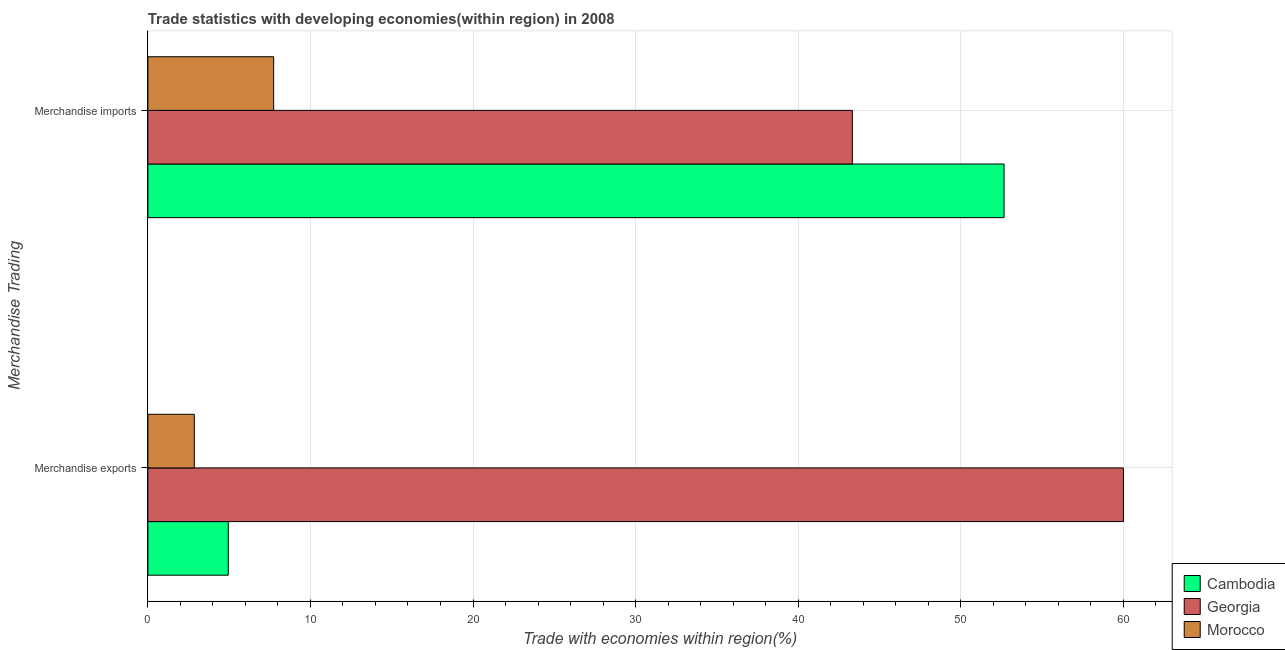How many different coloured bars are there?
Make the answer very short. 3. Are the number of bars per tick equal to the number of legend labels?
Provide a short and direct response. Yes. What is the label of the 2nd group of bars from the top?
Provide a short and direct response. Merchandise exports. What is the merchandise exports in Georgia?
Your answer should be compact. 60.01. Across all countries, what is the maximum merchandise imports?
Keep it short and to the point. 52.67. Across all countries, what is the minimum merchandise exports?
Make the answer very short. 2.86. In which country was the merchandise imports maximum?
Your answer should be compact. Cambodia. In which country was the merchandise imports minimum?
Provide a succinct answer. Morocco. What is the total merchandise exports in the graph?
Your response must be concise. 67.81. What is the difference between the merchandise imports in Morocco and that in Georgia?
Offer a very short reply. -35.6. What is the difference between the merchandise exports in Cambodia and the merchandise imports in Georgia?
Make the answer very short. -38.39. What is the average merchandise imports per country?
Offer a very short reply. 34.58. What is the difference between the merchandise imports and merchandise exports in Cambodia?
Provide a succinct answer. 47.72. What is the ratio of the merchandise imports in Cambodia to that in Morocco?
Your response must be concise. 6.81. Is the merchandise imports in Georgia less than that in Cambodia?
Offer a very short reply. Yes. In how many countries, is the merchandise imports greater than the average merchandise imports taken over all countries?
Your response must be concise. 2. What does the 2nd bar from the top in Merchandise exports represents?
Make the answer very short. Georgia. What does the 1st bar from the bottom in Merchandise exports represents?
Offer a very short reply. Cambodia. Are all the bars in the graph horizontal?
Make the answer very short. Yes. How many countries are there in the graph?
Ensure brevity in your answer.  3. Are the values on the major ticks of X-axis written in scientific E-notation?
Your answer should be compact. No. What is the title of the graph?
Provide a succinct answer. Trade statistics with developing economies(within region) in 2008. What is the label or title of the X-axis?
Your answer should be very brief. Trade with economies within region(%). What is the label or title of the Y-axis?
Provide a short and direct response. Merchandise Trading. What is the Trade with economies within region(%) in Cambodia in Merchandise exports?
Your answer should be very brief. 4.95. What is the Trade with economies within region(%) of Georgia in Merchandise exports?
Provide a succinct answer. 60.01. What is the Trade with economies within region(%) of Morocco in Merchandise exports?
Your response must be concise. 2.86. What is the Trade with economies within region(%) in Cambodia in Merchandise imports?
Give a very brief answer. 52.67. What is the Trade with economies within region(%) in Georgia in Merchandise imports?
Offer a terse response. 43.33. What is the Trade with economies within region(%) of Morocco in Merchandise imports?
Make the answer very short. 7.74. Across all Merchandise Trading, what is the maximum Trade with economies within region(%) in Cambodia?
Your answer should be compact. 52.67. Across all Merchandise Trading, what is the maximum Trade with economies within region(%) in Georgia?
Your response must be concise. 60.01. Across all Merchandise Trading, what is the maximum Trade with economies within region(%) in Morocco?
Keep it short and to the point. 7.74. Across all Merchandise Trading, what is the minimum Trade with economies within region(%) in Cambodia?
Your answer should be very brief. 4.95. Across all Merchandise Trading, what is the minimum Trade with economies within region(%) of Georgia?
Your answer should be very brief. 43.33. Across all Merchandise Trading, what is the minimum Trade with economies within region(%) of Morocco?
Provide a succinct answer. 2.86. What is the total Trade with economies within region(%) in Cambodia in the graph?
Offer a very short reply. 57.61. What is the total Trade with economies within region(%) in Georgia in the graph?
Your response must be concise. 103.34. What is the total Trade with economies within region(%) of Morocco in the graph?
Your answer should be compact. 10.59. What is the difference between the Trade with economies within region(%) of Cambodia in Merchandise exports and that in Merchandise imports?
Your answer should be compact. -47.72. What is the difference between the Trade with economies within region(%) in Georgia in Merchandise exports and that in Merchandise imports?
Ensure brevity in your answer.  16.67. What is the difference between the Trade with economies within region(%) in Morocco in Merchandise exports and that in Merchandise imports?
Ensure brevity in your answer.  -4.88. What is the difference between the Trade with economies within region(%) in Cambodia in Merchandise exports and the Trade with economies within region(%) in Georgia in Merchandise imports?
Keep it short and to the point. -38.39. What is the difference between the Trade with economies within region(%) in Cambodia in Merchandise exports and the Trade with economies within region(%) in Morocco in Merchandise imports?
Provide a succinct answer. -2.79. What is the difference between the Trade with economies within region(%) of Georgia in Merchandise exports and the Trade with economies within region(%) of Morocco in Merchandise imports?
Give a very brief answer. 52.27. What is the average Trade with economies within region(%) in Cambodia per Merchandise Trading?
Provide a short and direct response. 28.81. What is the average Trade with economies within region(%) in Georgia per Merchandise Trading?
Keep it short and to the point. 51.67. What is the average Trade with economies within region(%) in Morocco per Merchandise Trading?
Keep it short and to the point. 5.3. What is the difference between the Trade with economies within region(%) in Cambodia and Trade with economies within region(%) in Georgia in Merchandise exports?
Offer a terse response. -55.06. What is the difference between the Trade with economies within region(%) in Cambodia and Trade with economies within region(%) in Morocco in Merchandise exports?
Make the answer very short. 2.09. What is the difference between the Trade with economies within region(%) of Georgia and Trade with economies within region(%) of Morocco in Merchandise exports?
Ensure brevity in your answer.  57.15. What is the difference between the Trade with economies within region(%) of Cambodia and Trade with economies within region(%) of Georgia in Merchandise imports?
Offer a terse response. 9.33. What is the difference between the Trade with economies within region(%) of Cambodia and Trade with economies within region(%) of Morocco in Merchandise imports?
Your answer should be very brief. 44.93. What is the difference between the Trade with economies within region(%) of Georgia and Trade with economies within region(%) of Morocco in Merchandise imports?
Provide a succinct answer. 35.6. What is the ratio of the Trade with economies within region(%) in Cambodia in Merchandise exports to that in Merchandise imports?
Your answer should be compact. 0.09. What is the ratio of the Trade with economies within region(%) in Georgia in Merchandise exports to that in Merchandise imports?
Ensure brevity in your answer.  1.38. What is the ratio of the Trade with economies within region(%) in Morocco in Merchandise exports to that in Merchandise imports?
Ensure brevity in your answer.  0.37. What is the difference between the highest and the second highest Trade with economies within region(%) in Cambodia?
Offer a very short reply. 47.72. What is the difference between the highest and the second highest Trade with economies within region(%) of Georgia?
Make the answer very short. 16.67. What is the difference between the highest and the second highest Trade with economies within region(%) in Morocco?
Keep it short and to the point. 4.88. What is the difference between the highest and the lowest Trade with economies within region(%) of Cambodia?
Your answer should be very brief. 47.72. What is the difference between the highest and the lowest Trade with economies within region(%) of Georgia?
Offer a very short reply. 16.67. What is the difference between the highest and the lowest Trade with economies within region(%) of Morocco?
Ensure brevity in your answer.  4.88. 